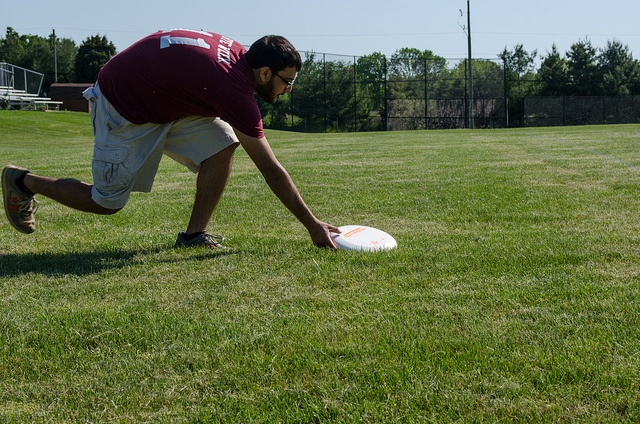Describe the objects in this image and their specific colors. I can see people in lightblue, black, blue, purple, and darkgreen tones and frisbee in lightblue, white, darkgray, gray, and tan tones in this image. 